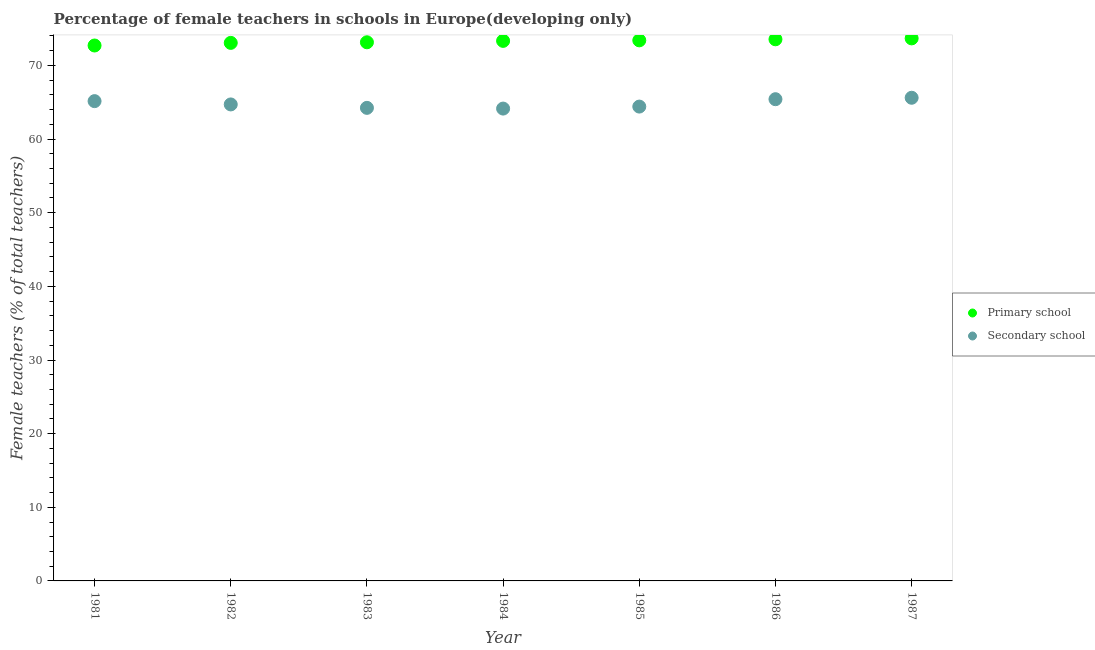How many different coloured dotlines are there?
Ensure brevity in your answer.  2. Is the number of dotlines equal to the number of legend labels?
Offer a terse response. Yes. What is the percentage of female teachers in primary schools in 1985?
Keep it short and to the point. 73.41. Across all years, what is the maximum percentage of female teachers in secondary schools?
Make the answer very short. 65.61. Across all years, what is the minimum percentage of female teachers in primary schools?
Your response must be concise. 72.71. In which year was the percentage of female teachers in secondary schools maximum?
Offer a terse response. 1987. In which year was the percentage of female teachers in primary schools minimum?
Provide a short and direct response. 1981. What is the total percentage of female teachers in primary schools in the graph?
Provide a succinct answer. 512.89. What is the difference between the percentage of female teachers in primary schools in 1981 and that in 1985?
Provide a succinct answer. -0.7. What is the difference between the percentage of female teachers in primary schools in 1982 and the percentage of female teachers in secondary schools in 1983?
Your response must be concise. 8.82. What is the average percentage of female teachers in primary schools per year?
Provide a succinct answer. 73.27. In the year 1981, what is the difference between the percentage of female teachers in primary schools and percentage of female teachers in secondary schools?
Keep it short and to the point. 7.55. In how many years, is the percentage of female teachers in secondary schools greater than 48 %?
Provide a succinct answer. 7. What is the ratio of the percentage of female teachers in secondary schools in 1983 to that in 1985?
Ensure brevity in your answer.  1. Is the percentage of female teachers in primary schools in 1981 less than that in 1985?
Keep it short and to the point. Yes. Is the difference between the percentage of female teachers in primary schools in 1982 and 1987 greater than the difference between the percentage of female teachers in secondary schools in 1982 and 1987?
Your response must be concise. Yes. What is the difference between the highest and the second highest percentage of female teachers in primary schools?
Your answer should be compact. 0.12. What is the difference between the highest and the lowest percentage of female teachers in primary schools?
Provide a short and direct response. 0.97. In how many years, is the percentage of female teachers in primary schools greater than the average percentage of female teachers in primary schools taken over all years?
Your answer should be compact. 4. Is the percentage of female teachers in primary schools strictly greater than the percentage of female teachers in secondary schools over the years?
Your answer should be compact. Yes. Is the percentage of female teachers in secondary schools strictly less than the percentage of female teachers in primary schools over the years?
Keep it short and to the point. Yes. How many dotlines are there?
Provide a succinct answer. 2. Does the graph contain any zero values?
Keep it short and to the point. No. How many legend labels are there?
Provide a short and direct response. 2. How are the legend labels stacked?
Your answer should be compact. Vertical. What is the title of the graph?
Your answer should be compact. Percentage of female teachers in schools in Europe(developing only). Does "Exports of goods" appear as one of the legend labels in the graph?
Keep it short and to the point. No. What is the label or title of the X-axis?
Provide a short and direct response. Year. What is the label or title of the Y-axis?
Your answer should be compact. Female teachers (% of total teachers). What is the Female teachers (% of total teachers) of Primary school in 1981?
Give a very brief answer. 72.71. What is the Female teachers (% of total teachers) of Secondary school in 1981?
Ensure brevity in your answer.  65.15. What is the Female teachers (% of total teachers) in Primary school in 1982?
Keep it short and to the point. 73.06. What is the Female teachers (% of total teachers) in Secondary school in 1982?
Your answer should be compact. 64.71. What is the Female teachers (% of total teachers) of Primary school in 1983?
Your answer should be compact. 73.15. What is the Female teachers (% of total teachers) of Secondary school in 1983?
Make the answer very short. 64.24. What is the Female teachers (% of total teachers) of Primary school in 1984?
Ensure brevity in your answer.  73.34. What is the Female teachers (% of total teachers) of Secondary school in 1984?
Keep it short and to the point. 64.14. What is the Female teachers (% of total teachers) of Primary school in 1985?
Provide a short and direct response. 73.41. What is the Female teachers (% of total teachers) in Secondary school in 1985?
Ensure brevity in your answer.  64.41. What is the Female teachers (% of total teachers) in Primary school in 1986?
Your response must be concise. 73.55. What is the Female teachers (% of total teachers) of Secondary school in 1986?
Your answer should be very brief. 65.42. What is the Female teachers (% of total teachers) in Primary school in 1987?
Give a very brief answer. 73.67. What is the Female teachers (% of total teachers) in Secondary school in 1987?
Your answer should be compact. 65.61. Across all years, what is the maximum Female teachers (% of total teachers) in Primary school?
Your answer should be very brief. 73.67. Across all years, what is the maximum Female teachers (% of total teachers) in Secondary school?
Ensure brevity in your answer.  65.61. Across all years, what is the minimum Female teachers (% of total teachers) of Primary school?
Your response must be concise. 72.71. Across all years, what is the minimum Female teachers (% of total teachers) in Secondary school?
Keep it short and to the point. 64.14. What is the total Female teachers (% of total teachers) of Primary school in the graph?
Give a very brief answer. 512.89. What is the total Female teachers (% of total teachers) in Secondary school in the graph?
Your response must be concise. 453.68. What is the difference between the Female teachers (% of total teachers) of Primary school in 1981 and that in 1982?
Provide a succinct answer. -0.36. What is the difference between the Female teachers (% of total teachers) of Secondary school in 1981 and that in 1982?
Make the answer very short. 0.45. What is the difference between the Female teachers (% of total teachers) in Primary school in 1981 and that in 1983?
Your answer should be compact. -0.44. What is the difference between the Female teachers (% of total teachers) of Secondary school in 1981 and that in 1983?
Ensure brevity in your answer.  0.91. What is the difference between the Female teachers (% of total teachers) in Primary school in 1981 and that in 1984?
Your answer should be compact. -0.63. What is the difference between the Female teachers (% of total teachers) in Secondary school in 1981 and that in 1984?
Offer a terse response. 1.01. What is the difference between the Female teachers (% of total teachers) in Primary school in 1981 and that in 1985?
Offer a terse response. -0.7. What is the difference between the Female teachers (% of total teachers) of Secondary school in 1981 and that in 1985?
Make the answer very short. 0.74. What is the difference between the Female teachers (% of total teachers) in Primary school in 1981 and that in 1986?
Your answer should be very brief. -0.84. What is the difference between the Female teachers (% of total teachers) of Secondary school in 1981 and that in 1986?
Give a very brief answer. -0.26. What is the difference between the Female teachers (% of total teachers) of Primary school in 1981 and that in 1987?
Give a very brief answer. -0.97. What is the difference between the Female teachers (% of total teachers) in Secondary school in 1981 and that in 1987?
Your answer should be compact. -0.46. What is the difference between the Female teachers (% of total teachers) of Primary school in 1982 and that in 1983?
Offer a terse response. -0.08. What is the difference between the Female teachers (% of total teachers) in Secondary school in 1982 and that in 1983?
Keep it short and to the point. 0.47. What is the difference between the Female teachers (% of total teachers) of Primary school in 1982 and that in 1984?
Your answer should be very brief. -0.27. What is the difference between the Female teachers (% of total teachers) in Secondary school in 1982 and that in 1984?
Provide a short and direct response. 0.56. What is the difference between the Female teachers (% of total teachers) in Primary school in 1982 and that in 1985?
Provide a short and direct response. -0.34. What is the difference between the Female teachers (% of total teachers) in Secondary school in 1982 and that in 1985?
Your response must be concise. 0.29. What is the difference between the Female teachers (% of total teachers) of Primary school in 1982 and that in 1986?
Offer a terse response. -0.49. What is the difference between the Female teachers (% of total teachers) of Secondary school in 1982 and that in 1986?
Your response must be concise. -0.71. What is the difference between the Female teachers (% of total teachers) of Primary school in 1982 and that in 1987?
Ensure brevity in your answer.  -0.61. What is the difference between the Female teachers (% of total teachers) in Secondary school in 1982 and that in 1987?
Your answer should be very brief. -0.91. What is the difference between the Female teachers (% of total teachers) of Primary school in 1983 and that in 1984?
Keep it short and to the point. -0.19. What is the difference between the Female teachers (% of total teachers) in Secondary school in 1983 and that in 1984?
Provide a short and direct response. 0.1. What is the difference between the Female teachers (% of total teachers) of Primary school in 1983 and that in 1985?
Your response must be concise. -0.26. What is the difference between the Female teachers (% of total teachers) in Secondary school in 1983 and that in 1985?
Provide a short and direct response. -0.17. What is the difference between the Female teachers (% of total teachers) of Primary school in 1983 and that in 1986?
Provide a short and direct response. -0.41. What is the difference between the Female teachers (% of total teachers) in Secondary school in 1983 and that in 1986?
Your response must be concise. -1.18. What is the difference between the Female teachers (% of total teachers) of Primary school in 1983 and that in 1987?
Ensure brevity in your answer.  -0.53. What is the difference between the Female teachers (% of total teachers) of Secondary school in 1983 and that in 1987?
Provide a short and direct response. -1.37. What is the difference between the Female teachers (% of total teachers) in Primary school in 1984 and that in 1985?
Your answer should be very brief. -0.07. What is the difference between the Female teachers (% of total teachers) of Secondary school in 1984 and that in 1985?
Your response must be concise. -0.27. What is the difference between the Female teachers (% of total teachers) of Primary school in 1984 and that in 1986?
Give a very brief answer. -0.22. What is the difference between the Female teachers (% of total teachers) in Secondary school in 1984 and that in 1986?
Ensure brevity in your answer.  -1.27. What is the difference between the Female teachers (% of total teachers) of Primary school in 1984 and that in 1987?
Keep it short and to the point. -0.34. What is the difference between the Female teachers (% of total teachers) in Secondary school in 1984 and that in 1987?
Make the answer very short. -1.47. What is the difference between the Female teachers (% of total teachers) of Primary school in 1985 and that in 1986?
Your response must be concise. -0.14. What is the difference between the Female teachers (% of total teachers) of Secondary school in 1985 and that in 1986?
Provide a succinct answer. -1. What is the difference between the Female teachers (% of total teachers) of Primary school in 1985 and that in 1987?
Keep it short and to the point. -0.27. What is the difference between the Female teachers (% of total teachers) of Secondary school in 1985 and that in 1987?
Your answer should be compact. -1.2. What is the difference between the Female teachers (% of total teachers) in Primary school in 1986 and that in 1987?
Your response must be concise. -0.12. What is the difference between the Female teachers (% of total teachers) in Secondary school in 1986 and that in 1987?
Keep it short and to the point. -0.2. What is the difference between the Female teachers (% of total teachers) of Primary school in 1981 and the Female teachers (% of total teachers) of Secondary school in 1982?
Provide a succinct answer. 8. What is the difference between the Female teachers (% of total teachers) of Primary school in 1981 and the Female teachers (% of total teachers) of Secondary school in 1983?
Offer a terse response. 8.47. What is the difference between the Female teachers (% of total teachers) in Primary school in 1981 and the Female teachers (% of total teachers) in Secondary school in 1984?
Offer a very short reply. 8.57. What is the difference between the Female teachers (% of total teachers) of Primary school in 1981 and the Female teachers (% of total teachers) of Secondary school in 1985?
Provide a succinct answer. 8.29. What is the difference between the Female teachers (% of total teachers) of Primary school in 1981 and the Female teachers (% of total teachers) of Secondary school in 1986?
Give a very brief answer. 7.29. What is the difference between the Female teachers (% of total teachers) in Primary school in 1981 and the Female teachers (% of total teachers) in Secondary school in 1987?
Keep it short and to the point. 7.1. What is the difference between the Female teachers (% of total teachers) of Primary school in 1982 and the Female teachers (% of total teachers) of Secondary school in 1983?
Your answer should be compact. 8.82. What is the difference between the Female teachers (% of total teachers) of Primary school in 1982 and the Female teachers (% of total teachers) of Secondary school in 1984?
Keep it short and to the point. 8.92. What is the difference between the Female teachers (% of total teachers) in Primary school in 1982 and the Female teachers (% of total teachers) in Secondary school in 1985?
Give a very brief answer. 8.65. What is the difference between the Female teachers (% of total teachers) in Primary school in 1982 and the Female teachers (% of total teachers) in Secondary school in 1986?
Offer a terse response. 7.65. What is the difference between the Female teachers (% of total teachers) of Primary school in 1982 and the Female teachers (% of total teachers) of Secondary school in 1987?
Provide a succinct answer. 7.45. What is the difference between the Female teachers (% of total teachers) of Primary school in 1983 and the Female teachers (% of total teachers) of Secondary school in 1984?
Give a very brief answer. 9. What is the difference between the Female teachers (% of total teachers) of Primary school in 1983 and the Female teachers (% of total teachers) of Secondary school in 1985?
Keep it short and to the point. 8.73. What is the difference between the Female teachers (% of total teachers) in Primary school in 1983 and the Female teachers (% of total teachers) in Secondary school in 1986?
Provide a short and direct response. 7.73. What is the difference between the Female teachers (% of total teachers) of Primary school in 1983 and the Female teachers (% of total teachers) of Secondary school in 1987?
Offer a very short reply. 7.53. What is the difference between the Female teachers (% of total teachers) of Primary school in 1984 and the Female teachers (% of total teachers) of Secondary school in 1985?
Your answer should be compact. 8.92. What is the difference between the Female teachers (% of total teachers) of Primary school in 1984 and the Female teachers (% of total teachers) of Secondary school in 1986?
Your answer should be very brief. 7.92. What is the difference between the Female teachers (% of total teachers) of Primary school in 1984 and the Female teachers (% of total teachers) of Secondary school in 1987?
Offer a terse response. 7.72. What is the difference between the Female teachers (% of total teachers) of Primary school in 1985 and the Female teachers (% of total teachers) of Secondary school in 1986?
Your answer should be very brief. 7.99. What is the difference between the Female teachers (% of total teachers) in Primary school in 1985 and the Female teachers (% of total teachers) in Secondary school in 1987?
Offer a very short reply. 7.8. What is the difference between the Female teachers (% of total teachers) in Primary school in 1986 and the Female teachers (% of total teachers) in Secondary school in 1987?
Provide a succinct answer. 7.94. What is the average Female teachers (% of total teachers) in Primary school per year?
Your response must be concise. 73.27. What is the average Female teachers (% of total teachers) of Secondary school per year?
Offer a very short reply. 64.81. In the year 1981, what is the difference between the Female teachers (% of total teachers) in Primary school and Female teachers (% of total teachers) in Secondary school?
Your answer should be very brief. 7.55. In the year 1982, what is the difference between the Female teachers (% of total teachers) of Primary school and Female teachers (% of total teachers) of Secondary school?
Give a very brief answer. 8.36. In the year 1983, what is the difference between the Female teachers (% of total teachers) of Primary school and Female teachers (% of total teachers) of Secondary school?
Offer a terse response. 8.9. In the year 1984, what is the difference between the Female teachers (% of total teachers) of Primary school and Female teachers (% of total teachers) of Secondary school?
Provide a succinct answer. 9.19. In the year 1985, what is the difference between the Female teachers (% of total teachers) in Primary school and Female teachers (% of total teachers) in Secondary school?
Your answer should be compact. 8.99. In the year 1986, what is the difference between the Female teachers (% of total teachers) of Primary school and Female teachers (% of total teachers) of Secondary school?
Your answer should be very brief. 8.14. In the year 1987, what is the difference between the Female teachers (% of total teachers) of Primary school and Female teachers (% of total teachers) of Secondary school?
Offer a terse response. 8.06. What is the ratio of the Female teachers (% of total teachers) of Secondary school in 1981 to that in 1983?
Keep it short and to the point. 1.01. What is the ratio of the Female teachers (% of total teachers) of Primary school in 1981 to that in 1984?
Offer a very short reply. 0.99. What is the ratio of the Female teachers (% of total teachers) of Secondary school in 1981 to that in 1984?
Keep it short and to the point. 1.02. What is the ratio of the Female teachers (% of total teachers) of Secondary school in 1981 to that in 1985?
Your answer should be compact. 1.01. What is the ratio of the Female teachers (% of total teachers) of Primary school in 1981 to that in 1987?
Offer a very short reply. 0.99. What is the ratio of the Female teachers (% of total teachers) in Secondary school in 1982 to that in 1983?
Your answer should be very brief. 1.01. What is the ratio of the Female teachers (% of total teachers) of Primary school in 1982 to that in 1984?
Offer a terse response. 1. What is the ratio of the Female teachers (% of total teachers) of Secondary school in 1982 to that in 1984?
Your answer should be very brief. 1.01. What is the ratio of the Female teachers (% of total teachers) in Secondary school in 1982 to that in 1985?
Make the answer very short. 1. What is the ratio of the Female teachers (% of total teachers) of Secondary school in 1982 to that in 1986?
Give a very brief answer. 0.99. What is the ratio of the Female teachers (% of total teachers) of Primary school in 1982 to that in 1987?
Your response must be concise. 0.99. What is the ratio of the Female teachers (% of total teachers) in Secondary school in 1982 to that in 1987?
Provide a short and direct response. 0.99. What is the ratio of the Female teachers (% of total teachers) of Secondary school in 1983 to that in 1985?
Offer a very short reply. 1. What is the ratio of the Female teachers (% of total teachers) of Primary school in 1983 to that in 1986?
Give a very brief answer. 0.99. What is the ratio of the Female teachers (% of total teachers) of Secondary school in 1983 to that in 1986?
Your answer should be compact. 0.98. What is the ratio of the Female teachers (% of total teachers) of Secondary school in 1983 to that in 1987?
Offer a very short reply. 0.98. What is the ratio of the Female teachers (% of total teachers) in Secondary school in 1984 to that in 1986?
Keep it short and to the point. 0.98. What is the ratio of the Female teachers (% of total teachers) in Primary school in 1984 to that in 1987?
Your response must be concise. 1. What is the ratio of the Female teachers (% of total teachers) in Secondary school in 1984 to that in 1987?
Ensure brevity in your answer.  0.98. What is the ratio of the Female teachers (% of total teachers) in Primary school in 1985 to that in 1986?
Your answer should be very brief. 1. What is the ratio of the Female teachers (% of total teachers) of Secondary school in 1985 to that in 1986?
Make the answer very short. 0.98. What is the ratio of the Female teachers (% of total teachers) in Primary school in 1985 to that in 1987?
Provide a short and direct response. 1. What is the ratio of the Female teachers (% of total teachers) in Secondary school in 1985 to that in 1987?
Your answer should be very brief. 0.98. What is the difference between the highest and the second highest Female teachers (% of total teachers) in Primary school?
Provide a succinct answer. 0.12. What is the difference between the highest and the second highest Female teachers (% of total teachers) in Secondary school?
Offer a terse response. 0.2. What is the difference between the highest and the lowest Female teachers (% of total teachers) of Primary school?
Provide a short and direct response. 0.97. What is the difference between the highest and the lowest Female teachers (% of total teachers) of Secondary school?
Offer a very short reply. 1.47. 